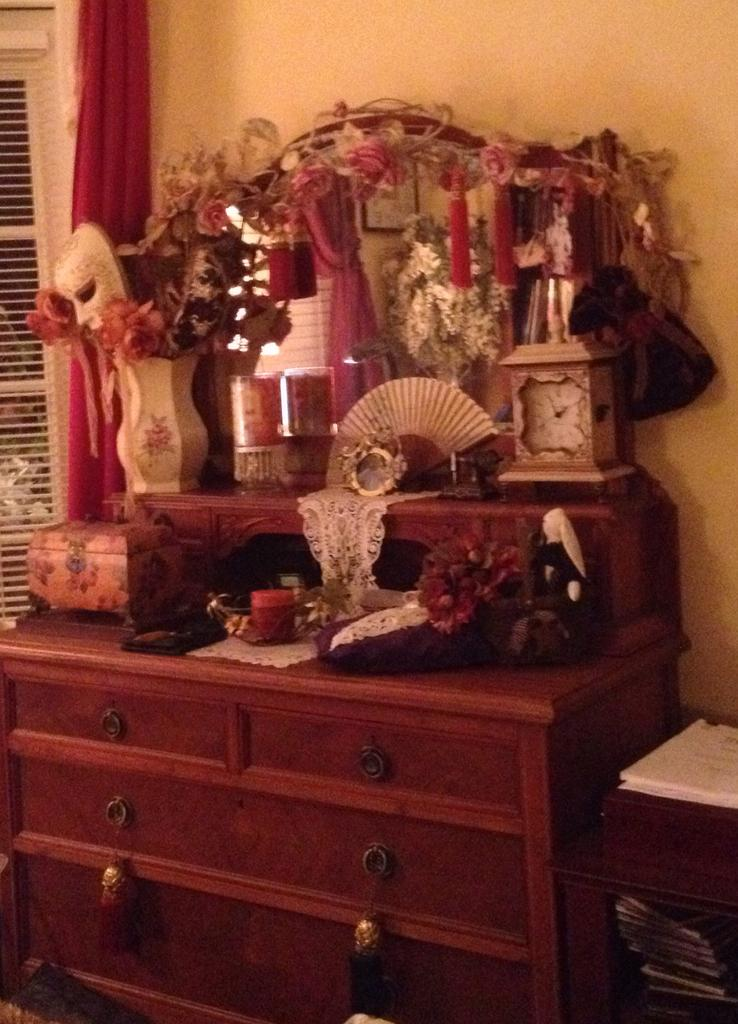What type of furniture is present in the image? There is a table in the image. What features does the table have? The table has cupboards and racks. What can be seen on the table? There is a flower pot, a vase, a hand fan, and a bottle on the table. Are there any other items on the table? Yes, there are other items on the table. What is visible in the background of the image? There is a wall, a window, and a curtain associated with the window in the background. Can you see any corn growing in the image? There is no corn visible in the image. What type of waves can be seen in the image? There are no waves present in the image. 